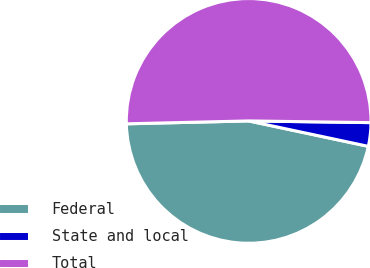<chart> <loc_0><loc_0><loc_500><loc_500><pie_chart><fcel>Federal<fcel>State and local<fcel>Total<nl><fcel>46.29%<fcel>3.11%<fcel>50.6%<nl></chart> 